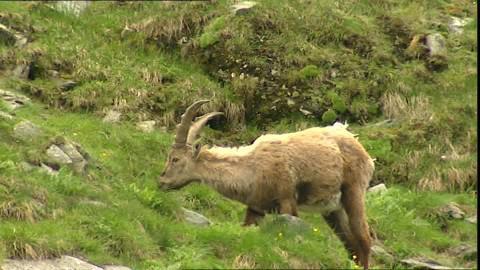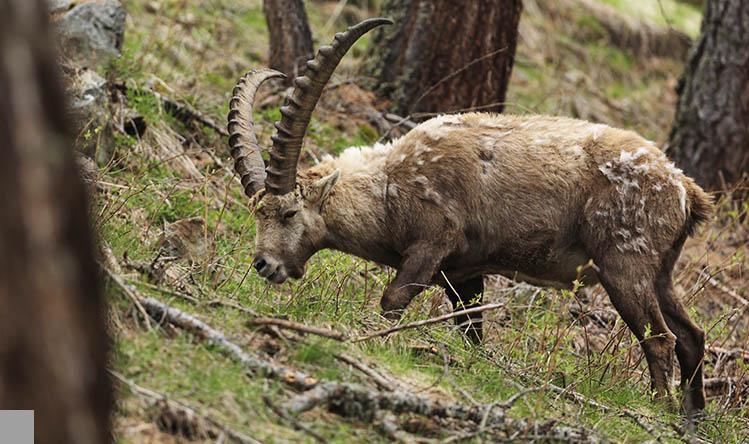The first image is the image on the left, the second image is the image on the right. Given the left and right images, does the statement "The right image shows a ram next to rocks." hold true? Answer yes or no. No. The first image is the image on the left, the second image is the image on the right. For the images displayed, is the sentence "Each imagine is one animal facing to the right" factually correct? Answer yes or no. No. 